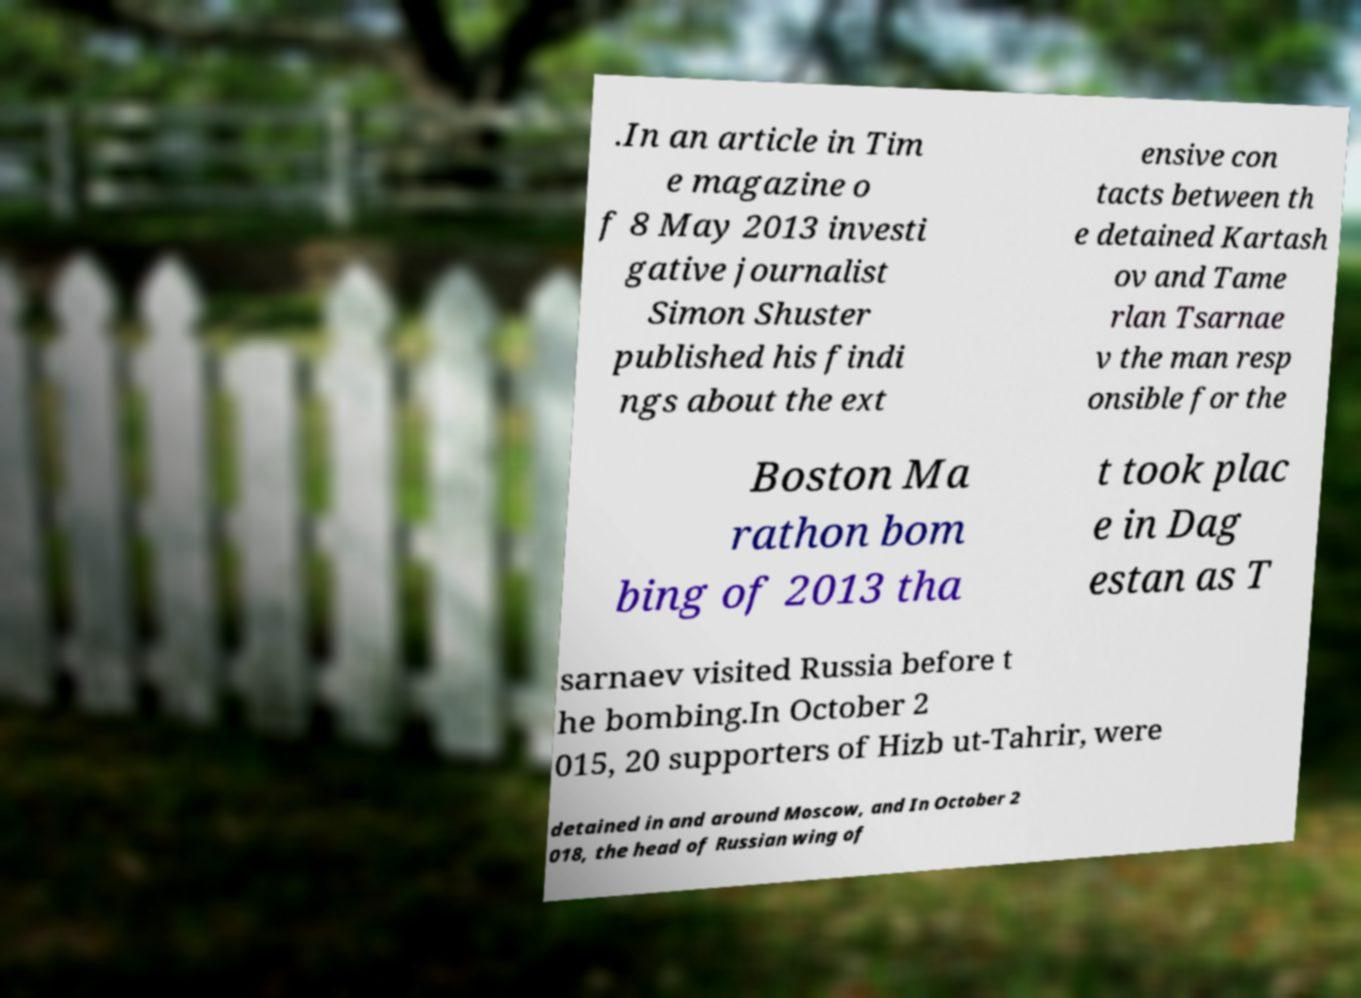Can you accurately transcribe the text from the provided image for me? .In an article in Tim e magazine o f 8 May 2013 investi gative journalist Simon Shuster published his findi ngs about the ext ensive con tacts between th e detained Kartash ov and Tame rlan Tsarnae v the man resp onsible for the Boston Ma rathon bom bing of 2013 tha t took plac e in Dag estan as T sarnaev visited Russia before t he bombing.In October 2 015, 20 supporters of Hizb ut-Tahrir, were detained in and around Moscow, and In October 2 018, the head of Russian wing of 